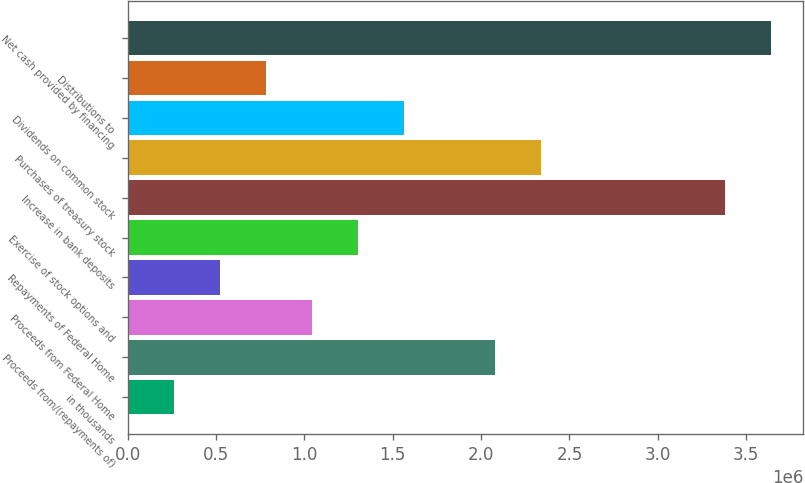<chart> <loc_0><loc_0><loc_500><loc_500><bar_chart><fcel>in thousands<fcel>Proceeds from/(repayments of)<fcel>Proceeds from Federal Home<fcel>Repayments of Federal Home<fcel>Exercise of stock options and<fcel>Increase in bank deposits<fcel>Purchases of treasury stock<fcel>Dividends on common stock<fcel>Distributions to<fcel>Net cash provided by financing<nl><fcel>260270<fcel>2.08084e+06<fcel>1.04052e+06<fcel>520352<fcel>1.3006e+06<fcel>3.38125e+06<fcel>2.34092e+06<fcel>1.56068e+06<fcel>780433<fcel>3.64133e+06<nl></chart> 